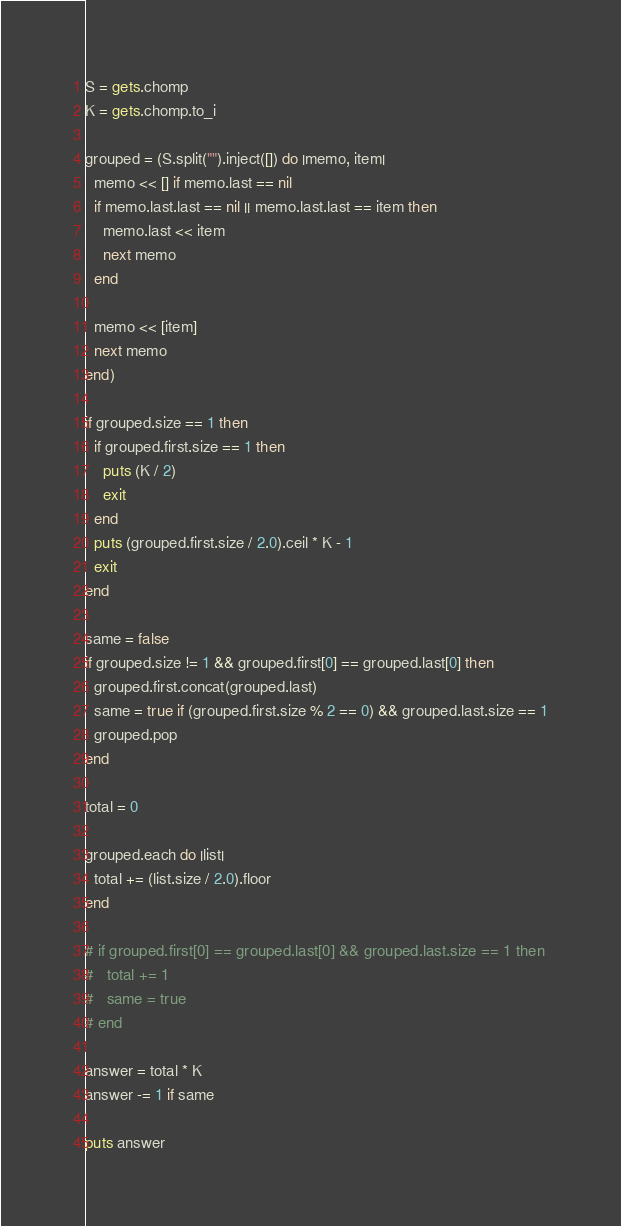<code> <loc_0><loc_0><loc_500><loc_500><_Ruby_>S = gets.chomp
K = gets.chomp.to_i

grouped = (S.split("").inject([]) do |memo, item|
  memo << [] if memo.last == nil
  if memo.last.last == nil || memo.last.last == item then
    memo.last << item
    next memo
  end

  memo << [item]
  next memo
end)

if grouped.size == 1 then
  if grouped.first.size == 1 then
    puts (K / 2)
    exit
  end
  puts (grouped.first.size / 2.0).ceil * K - 1
  exit
end

same = false
if grouped.size != 1 && grouped.first[0] == grouped.last[0] then
  grouped.first.concat(grouped.last)
  same = true if (grouped.first.size % 2 == 0) && grouped.last.size == 1
  grouped.pop
end

total = 0

grouped.each do |list|
  total += (list.size / 2.0).floor
end

# if grouped.first[0] == grouped.last[0] && grouped.last.size == 1 then
#   total += 1
#   same = true
# end

answer = total * K
answer -= 1 if same

puts answer</code> 